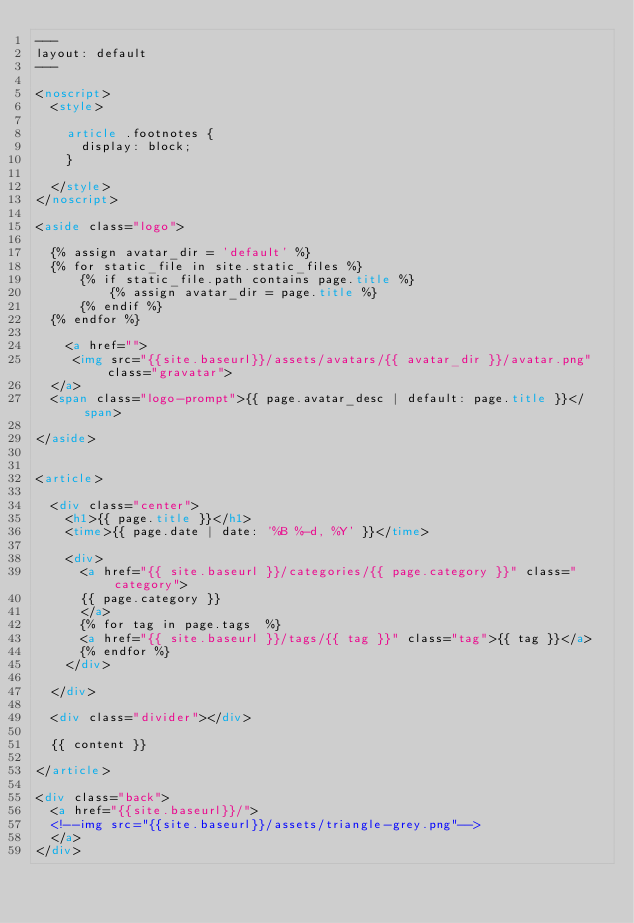Convert code to text. <code><loc_0><loc_0><loc_500><loc_500><_HTML_>---
layout: default
---

<noscript>
	<style>

		article .footnotes {
			display: block;
		}

	</style>
</noscript>

<aside class="logo">

  {% assign avatar_dir = 'default' %}
  {% for static_file in site.static_files %}
      {% if static_file.path contains page.title %}
          {% assign avatar_dir = page.title %}
      {% endif %}
  {% endfor %}
  
  	<a href="">
		 <img src="{{site.baseurl}}/assets/avatars/{{ avatar_dir }}/avatar.png" class="gravatar">
	</a>
	<span class="logo-prompt">{{ page.avatar_desc | default: page.title }}</span>

</aside>


<article>

	<div class="center">
		<h1>{{ page.title }}</h1>
		<time>{{ page.date | date: '%B %-d, %Y' }}</time>

		<div>
		  <a href="{{ site.baseurl }}/categories/{{ page.category }}" class="category">
			{{ page.category }}
		  </a>
		  {% for tag in page.tags  %}
		  <a href="{{ site.baseurl }}/tags/{{ tag }}" class="tag">{{ tag }}</a>
		  {% endfor %}
		</div>

	</div>
	
	<div class="divider"></div>

	{{ content }}

</article>

<div class="back">
  <a href="{{site.baseurl}}/">
	<!--img src="{{site.baseurl}}/assets/triangle-grey.png"-->
  </a>
</div>
</code> 